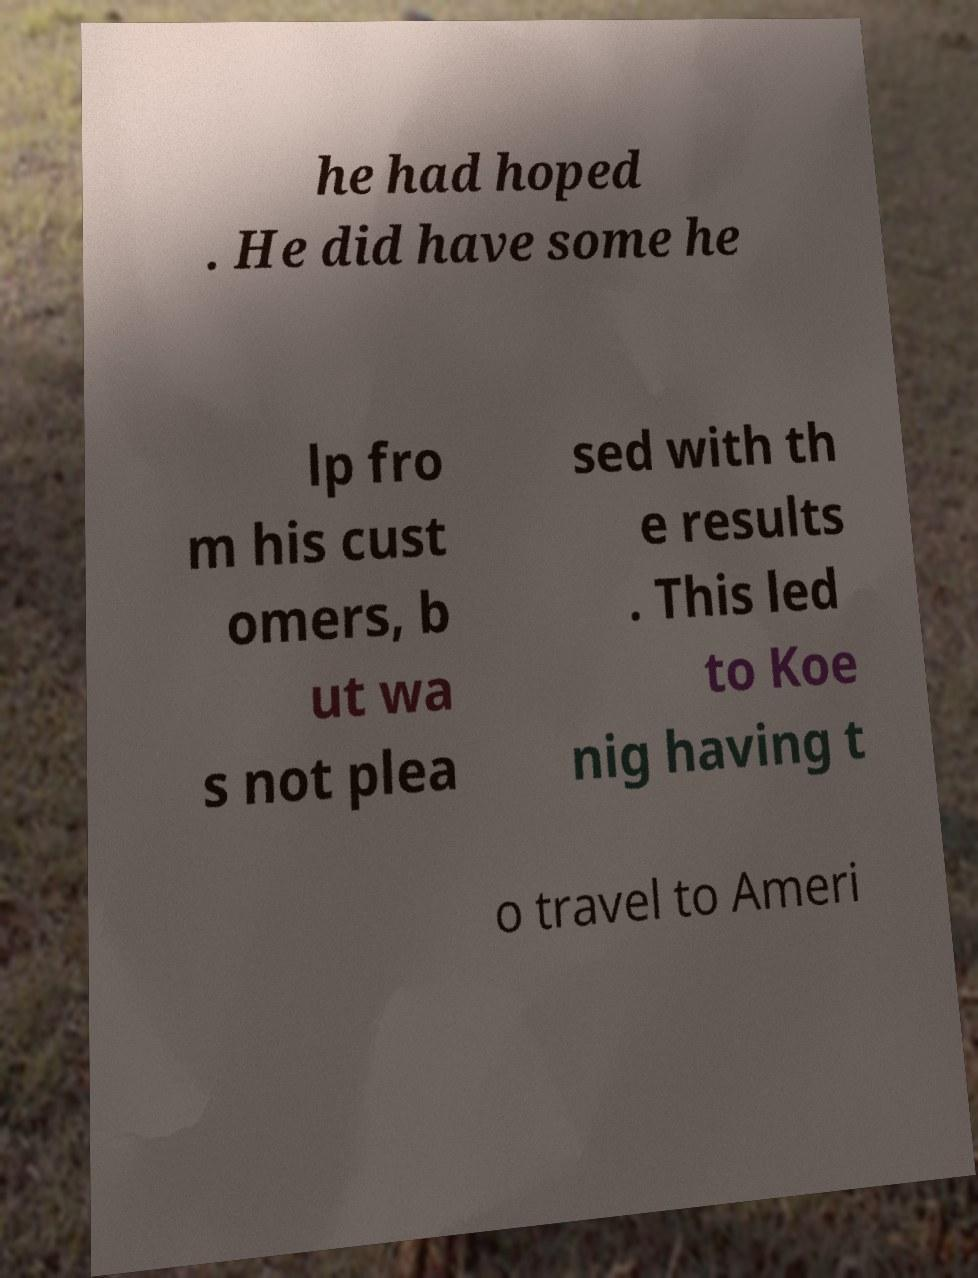Could you extract and type out the text from this image? he had hoped . He did have some he lp fro m his cust omers, b ut wa s not plea sed with th e results . This led to Koe nig having t o travel to Ameri 